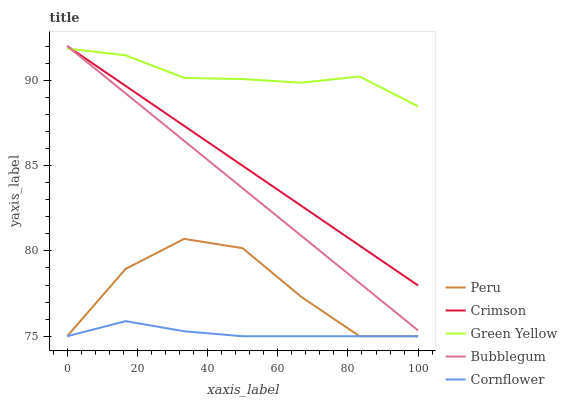Does Green Yellow have the minimum area under the curve?
Answer yes or no. No. Does Cornflower have the maximum area under the curve?
Answer yes or no. No. Is Cornflower the smoothest?
Answer yes or no. No. Is Cornflower the roughest?
Answer yes or no. No. Does Green Yellow have the lowest value?
Answer yes or no. No. Does Green Yellow have the highest value?
Answer yes or no. No. Is Peru less than Crimson?
Answer yes or no. Yes. Is Crimson greater than Cornflower?
Answer yes or no. Yes. Does Peru intersect Crimson?
Answer yes or no. No. 